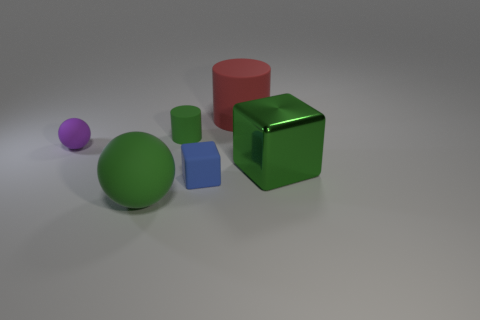Subtract all red cylinders. How many cylinders are left? 1 Add 1 purple balls. How many objects exist? 7 Subtract 1 spheres. How many spheres are left? 1 Subtract all spheres. How many objects are left? 4 Subtract all cyan cylinders. Subtract all red spheres. How many cylinders are left? 2 Subtract all yellow cylinders. How many purple balls are left? 1 Add 1 large shiny cubes. How many large shiny cubes exist? 2 Subtract 0 brown cylinders. How many objects are left? 6 Subtract all gray metallic cubes. Subtract all matte objects. How many objects are left? 1 Add 3 green things. How many green things are left? 6 